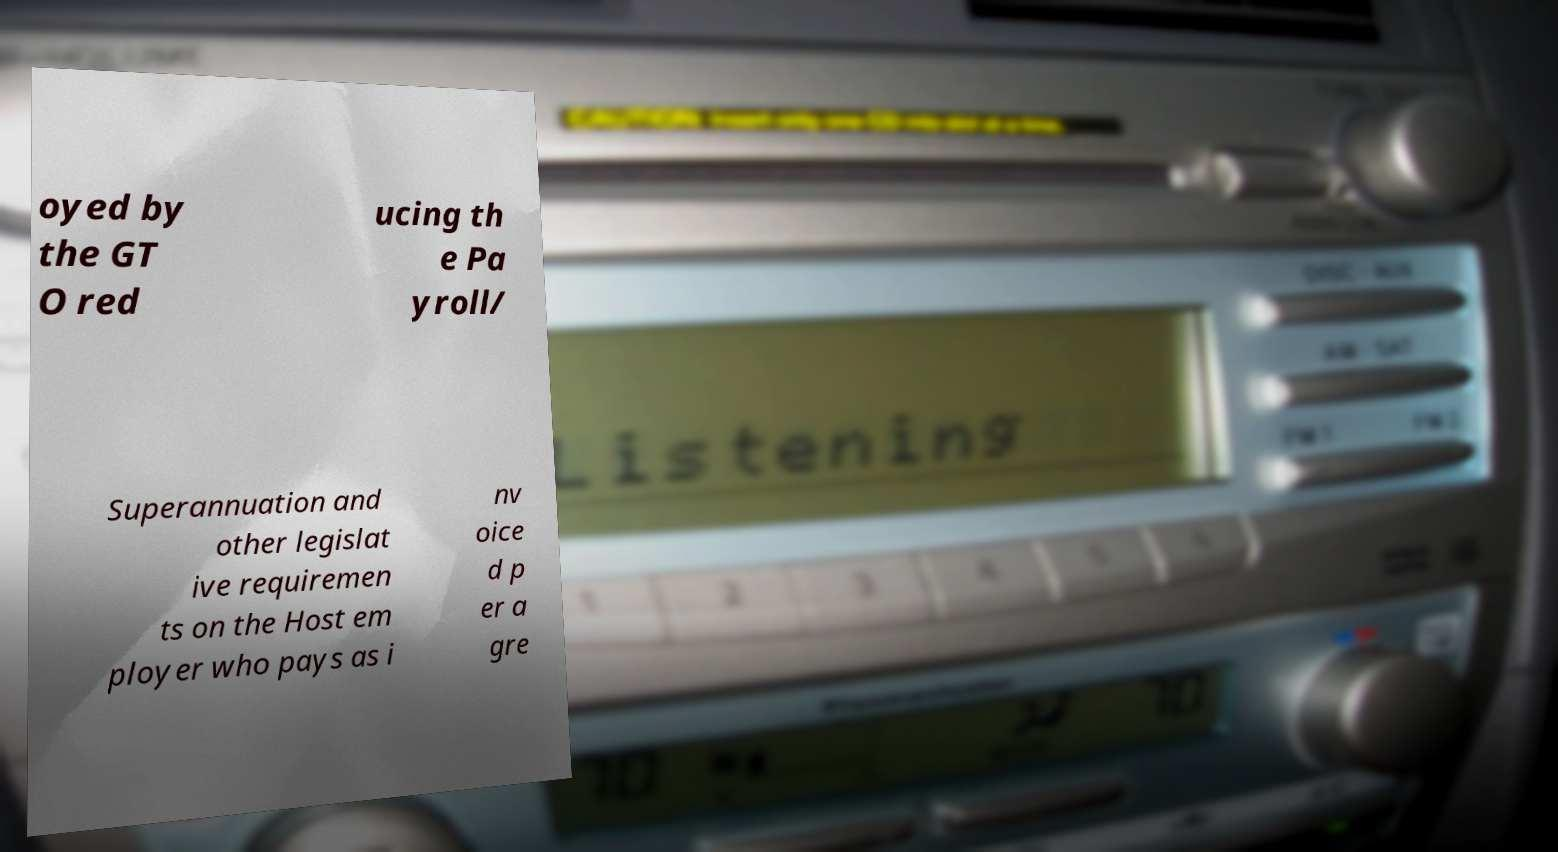There's text embedded in this image that I need extracted. Can you transcribe it verbatim? oyed by the GT O red ucing th e Pa yroll/ Superannuation and other legislat ive requiremen ts on the Host em ployer who pays as i nv oice d p er a gre 